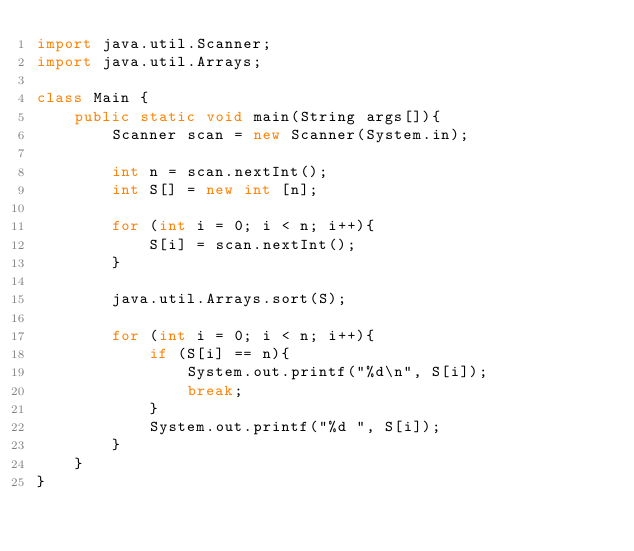Convert code to text. <code><loc_0><loc_0><loc_500><loc_500><_Java_>import java.util.Scanner;
import java.util.Arrays;

class Main {
	public static void main(String args[]){
		Scanner scan = new Scanner(System.in);
		
		int n = scan.nextInt();
		int S[] = new int [n];
		
		for (int i = 0; i < n; i++){
			S[i] = scan.nextInt();
		}
		
		java.util.Arrays.sort(S);
		
		for (int i = 0; i < n; i++){
			if (S[i] == n){
				System.out.printf("%d\n", S[i]);
				break;
			}
			System.out.printf("%d ", S[i]);
		}
	}
}</code> 